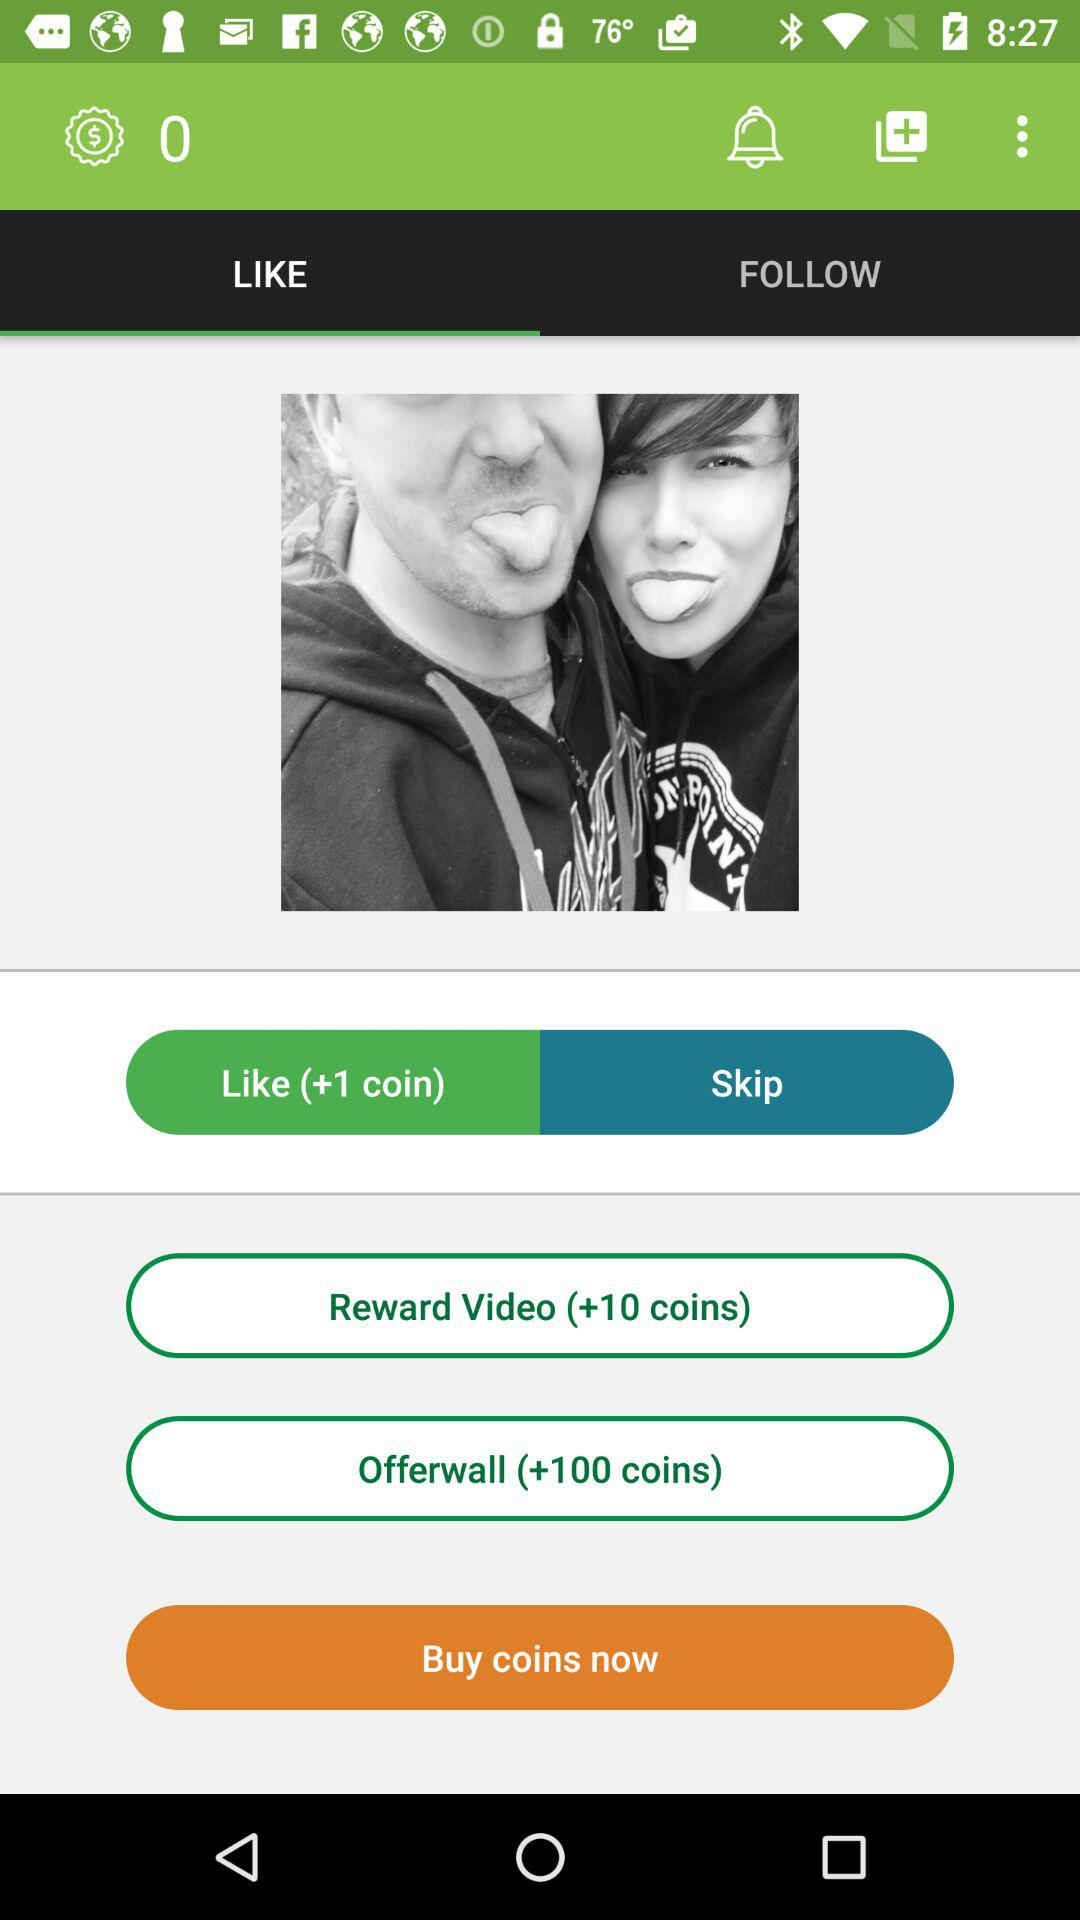What is the number of coins in the reward video? The number of coins in the reward video is +10. 